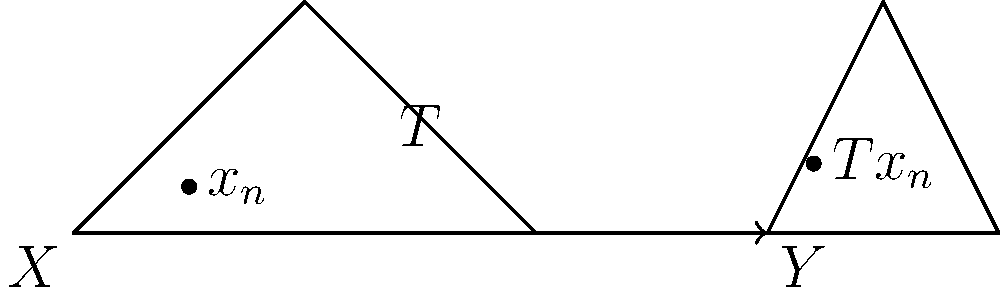Consider two Fréchet spaces $X$ and $Y$, and a linear operator $T: X \rightarrow Y$. Given a sequence $(x_n)$ in $X$ that converges to $0$, and knowing that $(Tx_n)$ converges in $Y$, prove or disprove the continuity of $T$ at $0$. What additional information, if any, is needed to establish the continuity of $T$ on all of $X$? To approach this problem, let's follow these steps:

1) Recall that for a linear operator between Fréchet spaces, continuity at a single point implies continuity everywhere. Therefore, if we can prove continuity at 0, we'll have continuity on all of $X$.

2) For $T$ to be continuous at 0, we need to show that if $x_n \rightarrow 0$ in $X$, then $Tx_n \rightarrow 0$ in $Y$.

3) We're given that $(x_n)$ converges to $0$ in $X$, and that $(Tx_n)$ converges in $Y$. However, we're not told what $(Tx_n)$ converges to.

4) Let's say $(Tx_n)$ converges to some $y \in Y$. We need to determine if $y = 0$.

5) If $y \neq 0$, then $T$ would not be continuous at 0, as we'd have a sequence converging to 0 in $X$ whose image under $T$ doesn't converge to 0 in $Y$.

6) However, with the given information, we can't determine whether $y = 0$ or not. This means we can't prove or disprove the continuity of $T$ at 0.

7) To establish the continuity of $T$ at 0 (and thus on all of $X$), we would need the additional information that $(Tx_n)$ converges to 0 in $Y$.

8) If we had this information, we could conclude that $T$ is continuous at 0 and therefore continuous on all of $X$.

Therefore, the continuity of $T$ cannot be determined from the given information alone.
Answer: Cannot be determined; need to know if $(Tx_n)$ converges to 0 in $Y$. 